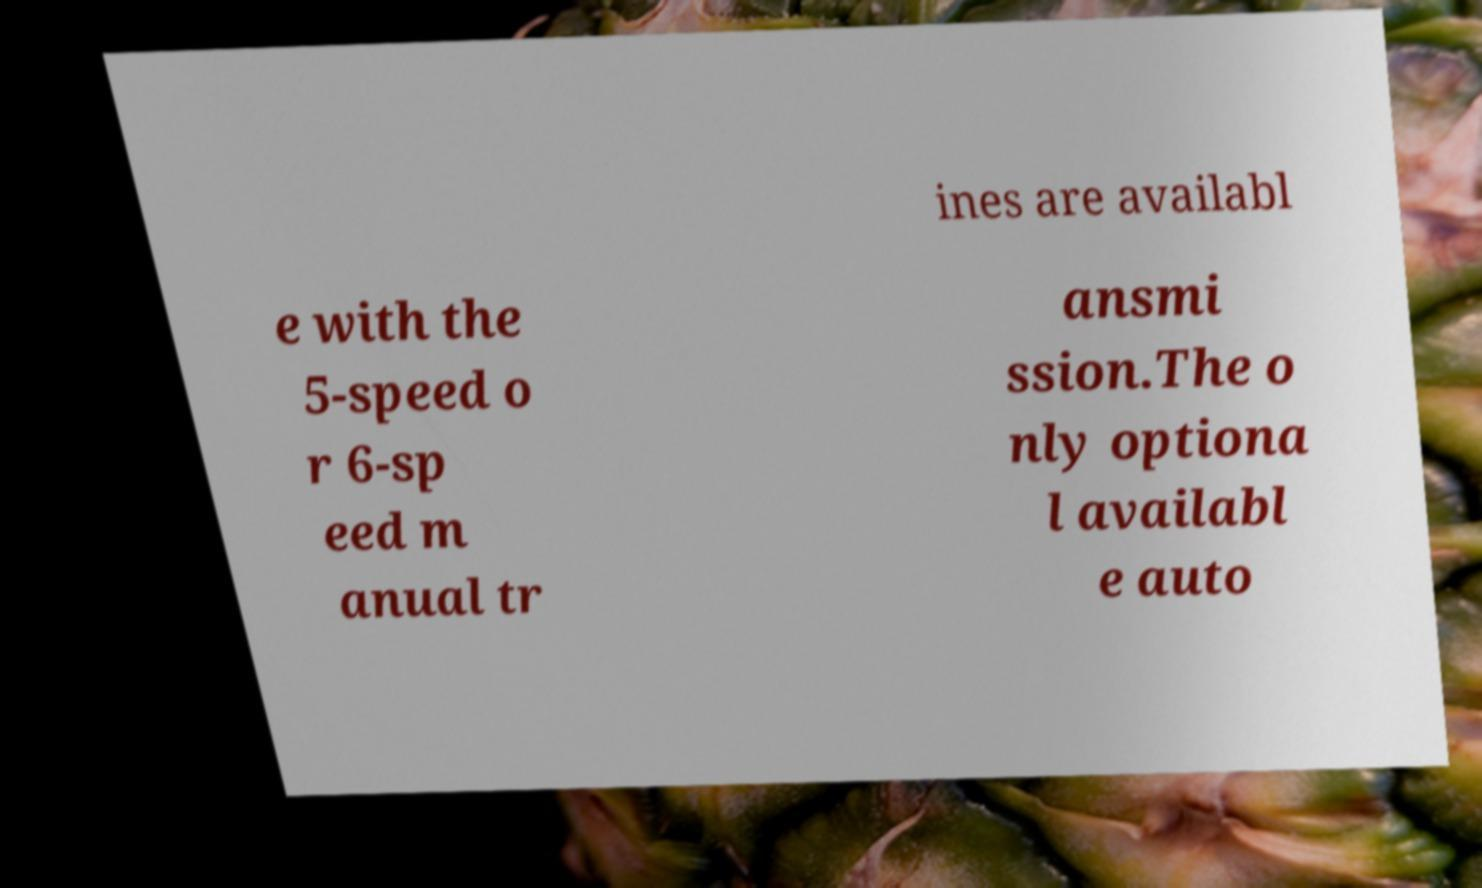I need the written content from this picture converted into text. Can you do that? ines are availabl e with the 5-speed o r 6-sp eed m anual tr ansmi ssion.The o nly optiona l availabl e auto 